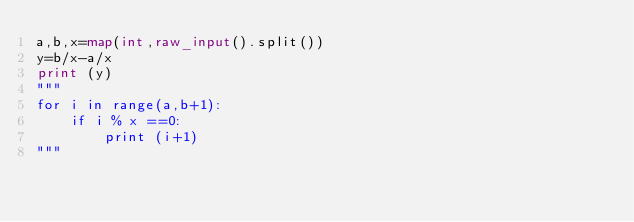Convert code to text. <code><loc_0><loc_0><loc_500><loc_500><_Python_>a,b,x=map(int,raw_input().split())
y=b/x-a/x
print (y)
"""
for i in range(a,b+1):
    if i % x ==0:
        print (i+1)
"""</code> 